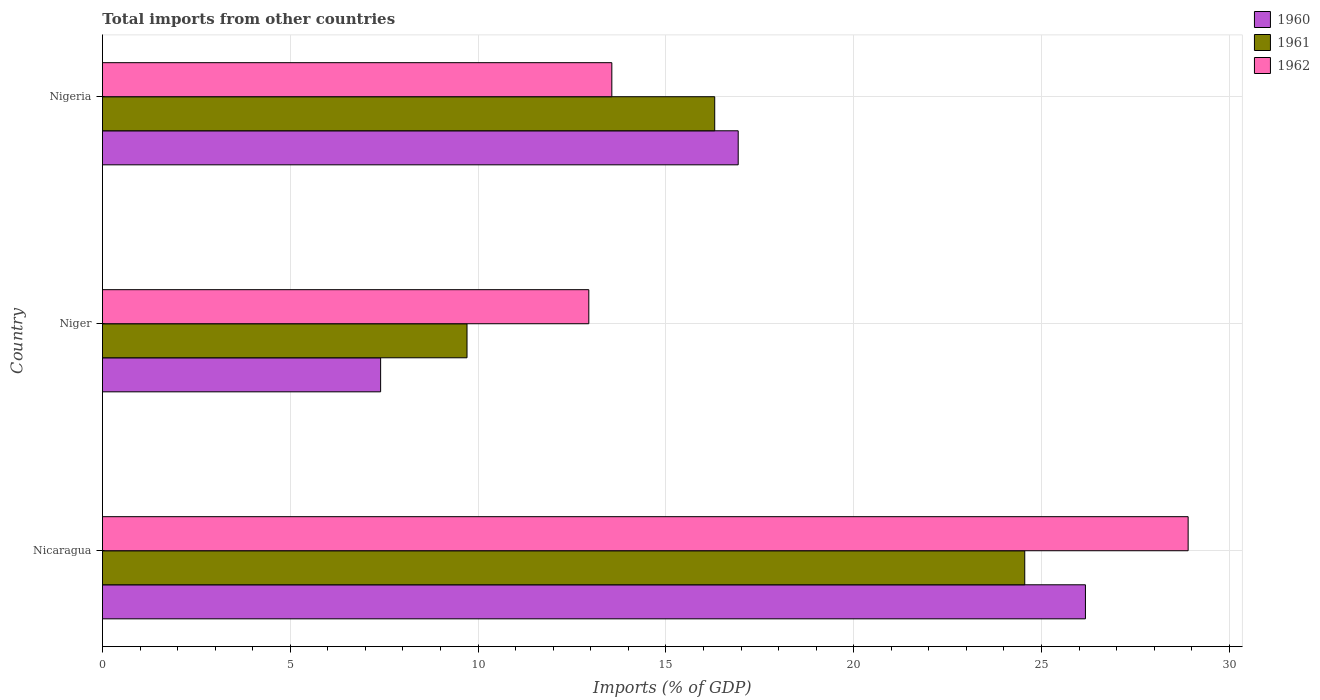How many groups of bars are there?
Make the answer very short. 3. Are the number of bars on each tick of the Y-axis equal?
Offer a terse response. Yes. What is the label of the 3rd group of bars from the top?
Make the answer very short. Nicaragua. What is the total imports in 1962 in Nicaragua?
Your response must be concise. 28.9. Across all countries, what is the maximum total imports in 1962?
Your response must be concise. 28.9. Across all countries, what is the minimum total imports in 1962?
Provide a succinct answer. 12.95. In which country was the total imports in 1960 maximum?
Give a very brief answer. Nicaragua. In which country was the total imports in 1960 minimum?
Your response must be concise. Niger. What is the total total imports in 1960 in the graph?
Provide a succinct answer. 50.5. What is the difference between the total imports in 1960 in Niger and that in Nigeria?
Your response must be concise. -9.52. What is the difference between the total imports in 1961 in Nicaragua and the total imports in 1960 in Niger?
Make the answer very short. 17.15. What is the average total imports in 1962 per country?
Your response must be concise. 18.47. What is the difference between the total imports in 1962 and total imports in 1961 in Nicaragua?
Your response must be concise. 4.35. What is the ratio of the total imports in 1960 in Nicaragua to that in Niger?
Ensure brevity in your answer.  3.53. Is the total imports in 1960 in Nicaragua less than that in Niger?
Offer a terse response. No. Is the difference between the total imports in 1962 in Nicaragua and Niger greater than the difference between the total imports in 1961 in Nicaragua and Niger?
Your answer should be compact. Yes. What is the difference between the highest and the second highest total imports in 1960?
Provide a short and direct response. 9.24. What is the difference between the highest and the lowest total imports in 1960?
Provide a succinct answer. 18.76. Is the sum of the total imports in 1960 in Nicaragua and Nigeria greater than the maximum total imports in 1961 across all countries?
Offer a terse response. Yes. What does the 1st bar from the top in Niger represents?
Provide a short and direct response. 1962. What does the 1st bar from the bottom in Nicaragua represents?
Make the answer very short. 1960. Is it the case that in every country, the sum of the total imports in 1960 and total imports in 1961 is greater than the total imports in 1962?
Make the answer very short. Yes. How many bars are there?
Provide a succinct answer. 9. Are all the bars in the graph horizontal?
Make the answer very short. Yes. How many countries are there in the graph?
Ensure brevity in your answer.  3. What is the difference between two consecutive major ticks on the X-axis?
Offer a terse response. 5. Does the graph contain grids?
Your answer should be very brief. Yes. Where does the legend appear in the graph?
Offer a very short reply. Top right. What is the title of the graph?
Offer a very short reply. Total imports from other countries. What is the label or title of the X-axis?
Give a very brief answer. Imports (% of GDP). What is the Imports (% of GDP) in 1960 in Nicaragua?
Your answer should be compact. 26.17. What is the Imports (% of GDP) in 1961 in Nicaragua?
Your answer should be compact. 24.55. What is the Imports (% of GDP) in 1962 in Nicaragua?
Offer a very short reply. 28.9. What is the Imports (% of GDP) in 1960 in Niger?
Your answer should be compact. 7.41. What is the Imports (% of GDP) in 1961 in Niger?
Make the answer very short. 9.71. What is the Imports (% of GDP) of 1962 in Niger?
Provide a short and direct response. 12.95. What is the Imports (% of GDP) of 1960 in Nigeria?
Ensure brevity in your answer.  16.92. What is the Imports (% of GDP) of 1961 in Nigeria?
Keep it short and to the point. 16.3. What is the Imports (% of GDP) in 1962 in Nigeria?
Keep it short and to the point. 13.56. Across all countries, what is the maximum Imports (% of GDP) of 1960?
Your answer should be compact. 26.17. Across all countries, what is the maximum Imports (% of GDP) in 1961?
Your answer should be very brief. 24.55. Across all countries, what is the maximum Imports (% of GDP) of 1962?
Your answer should be very brief. 28.9. Across all countries, what is the minimum Imports (% of GDP) of 1960?
Your response must be concise. 7.41. Across all countries, what is the minimum Imports (% of GDP) in 1961?
Give a very brief answer. 9.71. Across all countries, what is the minimum Imports (% of GDP) of 1962?
Offer a very short reply. 12.95. What is the total Imports (% of GDP) in 1960 in the graph?
Offer a very short reply. 50.5. What is the total Imports (% of GDP) of 1961 in the graph?
Ensure brevity in your answer.  50.56. What is the total Imports (% of GDP) in 1962 in the graph?
Your answer should be compact. 55.41. What is the difference between the Imports (% of GDP) of 1960 in Nicaragua and that in Niger?
Ensure brevity in your answer.  18.76. What is the difference between the Imports (% of GDP) of 1961 in Nicaragua and that in Niger?
Provide a short and direct response. 14.85. What is the difference between the Imports (% of GDP) of 1962 in Nicaragua and that in Niger?
Your answer should be compact. 15.96. What is the difference between the Imports (% of GDP) in 1960 in Nicaragua and that in Nigeria?
Your answer should be compact. 9.24. What is the difference between the Imports (% of GDP) of 1961 in Nicaragua and that in Nigeria?
Provide a short and direct response. 8.25. What is the difference between the Imports (% of GDP) of 1962 in Nicaragua and that in Nigeria?
Provide a succinct answer. 15.34. What is the difference between the Imports (% of GDP) of 1960 in Niger and that in Nigeria?
Make the answer very short. -9.52. What is the difference between the Imports (% of GDP) in 1961 in Niger and that in Nigeria?
Offer a terse response. -6.59. What is the difference between the Imports (% of GDP) of 1962 in Niger and that in Nigeria?
Your response must be concise. -0.61. What is the difference between the Imports (% of GDP) of 1960 in Nicaragua and the Imports (% of GDP) of 1961 in Niger?
Offer a terse response. 16.46. What is the difference between the Imports (% of GDP) in 1960 in Nicaragua and the Imports (% of GDP) in 1962 in Niger?
Your answer should be very brief. 13.22. What is the difference between the Imports (% of GDP) of 1961 in Nicaragua and the Imports (% of GDP) of 1962 in Niger?
Keep it short and to the point. 11.61. What is the difference between the Imports (% of GDP) in 1960 in Nicaragua and the Imports (% of GDP) in 1961 in Nigeria?
Your answer should be compact. 9.87. What is the difference between the Imports (% of GDP) of 1960 in Nicaragua and the Imports (% of GDP) of 1962 in Nigeria?
Offer a very short reply. 12.61. What is the difference between the Imports (% of GDP) in 1961 in Nicaragua and the Imports (% of GDP) in 1962 in Nigeria?
Ensure brevity in your answer.  10.99. What is the difference between the Imports (% of GDP) in 1960 in Niger and the Imports (% of GDP) in 1961 in Nigeria?
Give a very brief answer. -8.89. What is the difference between the Imports (% of GDP) in 1960 in Niger and the Imports (% of GDP) in 1962 in Nigeria?
Ensure brevity in your answer.  -6.16. What is the difference between the Imports (% of GDP) of 1961 in Niger and the Imports (% of GDP) of 1962 in Nigeria?
Offer a very short reply. -3.85. What is the average Imports (% of GDP) of 1960 per country?
Your response must be concise. 16.83. What is the average Imports (% of GDP) of 1961 per country?
Offer a very short reply. 16.85. What is the average Imports (% of GDP) of 1962 per country?
Ensure brevity in your answer.  18.47. What is the difference between the Imports (% of GDP) of 1960 and Imports (% of GDP) of 1961 in Nicaragua?
Provide a succinct answer. 1.62. What is the difference between the Imports (% of GDP) in 1960 and Imports (% of GDP) in 1962 in Nicaragua?
Keep it short and to the point. -2.73. What is the difference between the Imports (% of GDP) of 1961 and Imports (% of GDP) of 1962 in Nicaragua?
Offer a terse response. -4.35. What is the difference between the Imports (% of GDP) in 1960 and Imports (% of GDP) in 1962 in Niger?
Offer a very short reply. -5.54. What is the difference between the Imports (% of GDP) in 1961 and Imports (% of GDP) in 1962 in Niger?
Keep it short and to the point. -3.24. What is the difference between the Imports (% of GDP) of 1960 and Imports (% of GDP) of 1961 in Nigeria?
Your answer should be very brief. 0.63. What is the difference between the Imports (% of GDP) in 1960 and Imports (% of GDP) in 1962 in Nigeria?
Provide a short and direct response. 3.36. What is the difference between the Imports (% of GDP) in 1961 and Imports (% of GDP) in 1962 in Nigeria?
Provide a succinct answer. 2.74. What is the ratio of the Imports (% of GDP) in 1960 in Nicaragua to that in Niger?
Provide a short and direct response. 3.53. What is the ratio of the Imports (% of GDP) of 1961 in Nicaragua to that in Niger?
Keep it short and to the point. 2.53. What is the ratio of the Imports (% of GDP) of 1962 in Nicaragua to that in Niger?
Your answer should be very brief. 2.23. What is the ratio of the Imports (% of GDP) of 1960 in Nicaragua to that in Nigeria?
Give a very brief answer. 1.55. What is the ratio of the Imports (% of GDP) in 1961 in Nicaragua to that in Nigeria?
Ensure brevity in your answer.  1.51. What is the ratio of the Imports (% of GDP) in 1962 in Nicaragua to that in Nigeria?
Keep it short and to the point. 2.13. What is the ratio of the Imports (% of GDP) in 1960 in Niger to that in Nigeria?
Provide a succinct answer. 0.44. What is the ratio of the Imports (% of GDP) in 1961 in Niger to that in Nigeria?
Keep it short and to the point. 0.6. What is the ratio of the Imports (% of GDP) in 1962 in Niger to that in Nigeria?
Provide a succinct answer. 0.95. What is the difference between the highest and the second highest Imports (% of GDP) in 1960?
Provide a short and direct response. 9.24. What is the difference between the highest and the second highest Imports (% of GDP) in 1961?
Your response must be concise. 8.25. What is the difference between the highest and the second highest Imports (% of GDP) of 1962?
Your answer should be compact. 15.34. What is the difference between the highest and the lowest Imports (% of GDP) of 1960?
Provide a succinct answer. 18.76. What is the difference between the highest and the lowest Imports (% of GDP) of 1961?
Your answer should be very brief. 14.85. What is the difference between the highest and the lowest Imports (% of GDP) in 1962?
Ensure brevity in your answer.  15.96. 